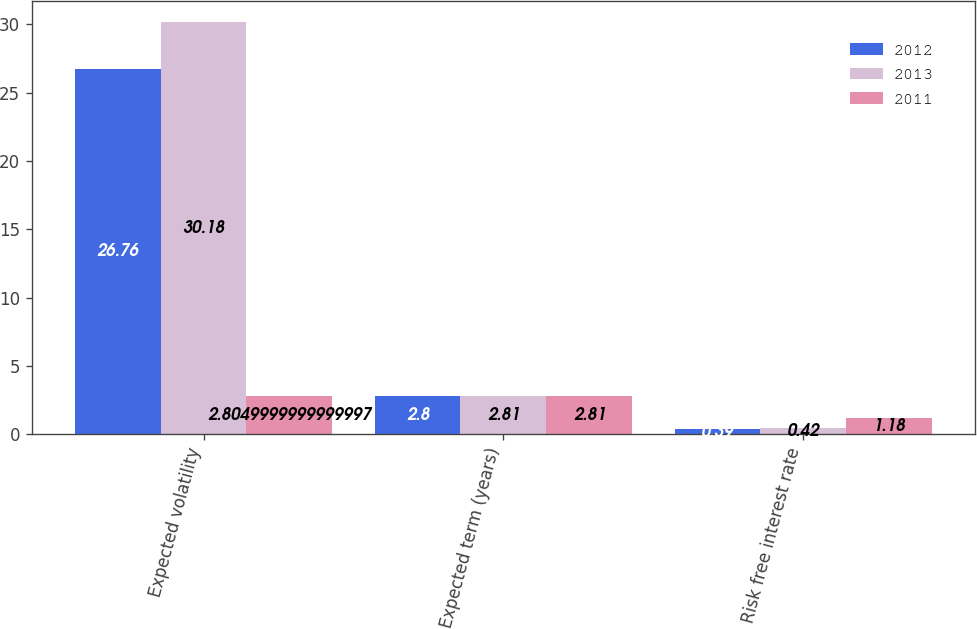<chart> <loc_0><loc_0><loc_500><loc_500><stacked_bar_chart><ecel><fcel>Expected volatility<fcel>Expected term (years)<fcel>Risk free interest rate<nl><fcel>2012<fcel>26.76<fcel>2.8<fcel>0.39<nl><fcel>2013<fcel>30.18<fcel>2.81<fcel>0.42<nl><fcel>2011<fcel>2.805<fcel>2.81<fcel>1.18<nl></chart> 